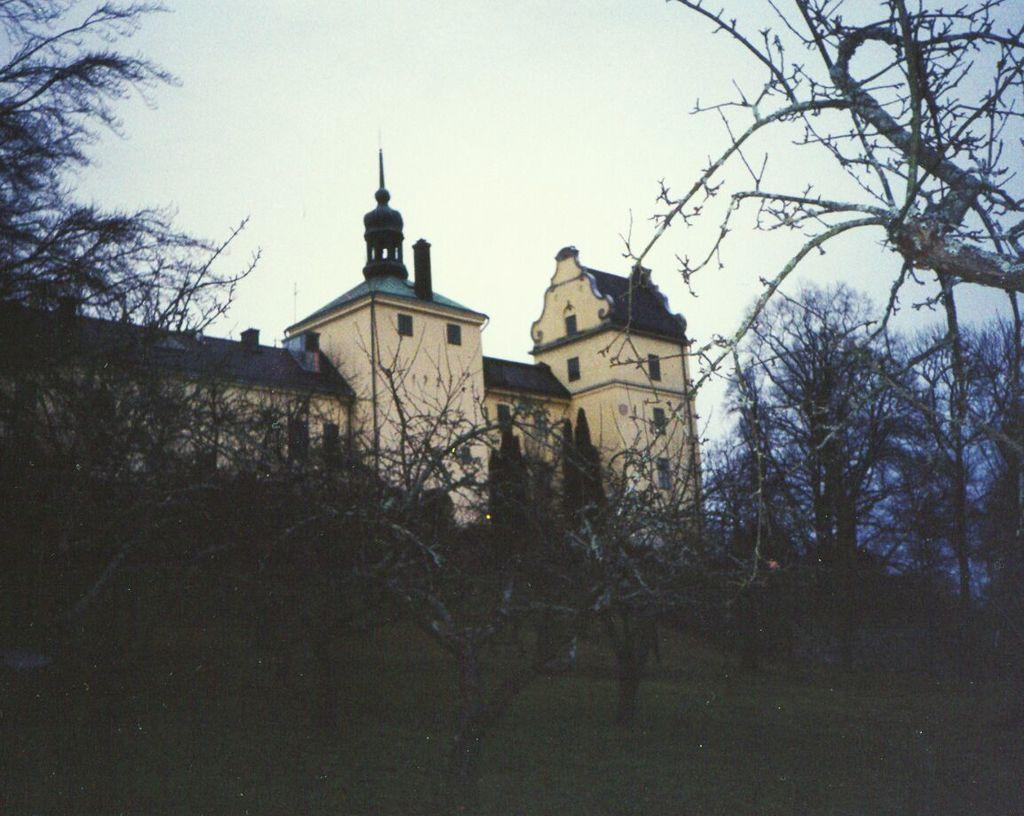What type of structure is present in the image? There is a building in the image. What feature can be seen on the building? The building has windows. What type of vegetation is present in the image? There are trees in the image. What can be seen in the background of the image? The sky is visible in the background of the image. Can you tell me where the veil is located in the image? There is no veil present in the image. What type of calculator can be seen on the roof of the building? There is no calculator present in the image. 